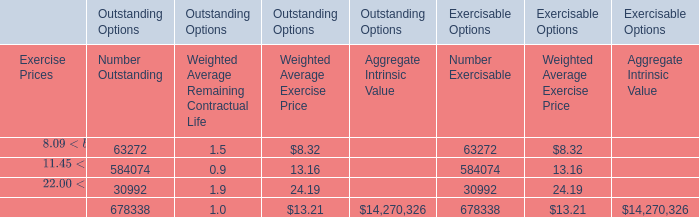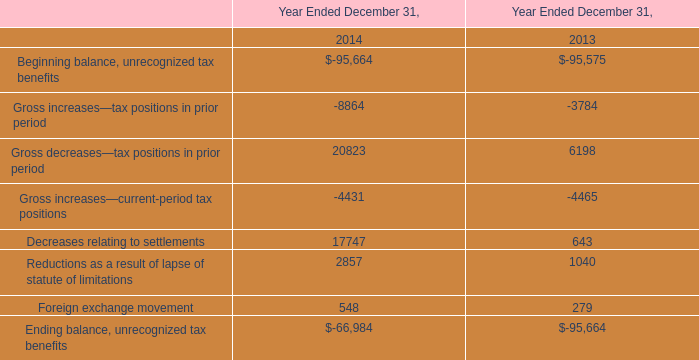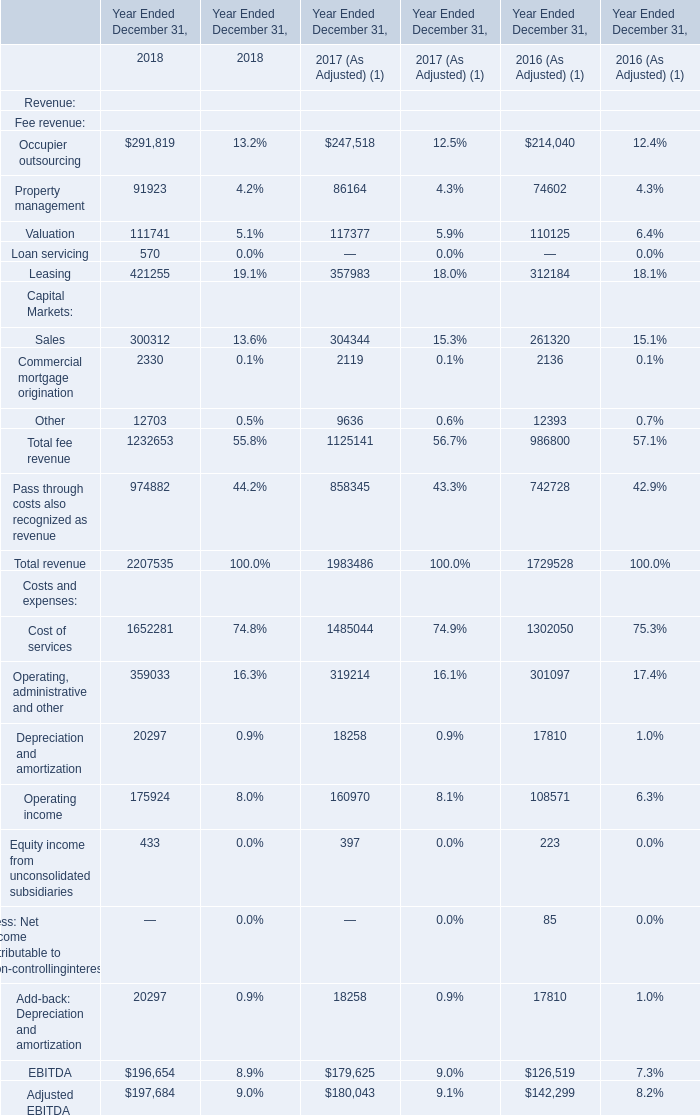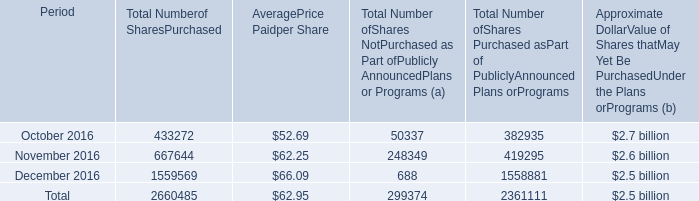as of december 31 , 2016 what was the percent of the shares outstanding of the 2015 program yet to be purchased 
Computations: (40 / 2.5)
Answer: 16.0. 